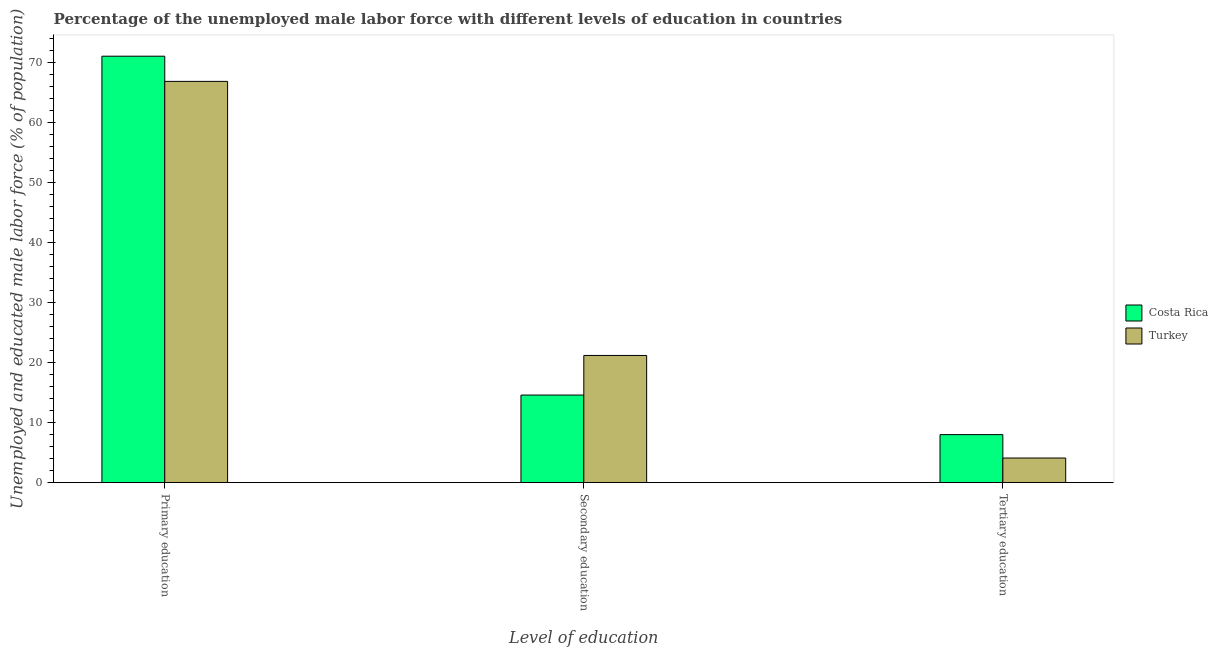How many different coloured bars are there?
Ensure brevity in your answer.  2. How many groups of bars are there?
Make the answer very short. 3. How many bars are there on the 1st tick from the right?
Give a very brief answer. 2. What is the label of the 2nd group of bars from the left?
Give a very brief answer. Secondary education. What is the percentage of male labor force who received secondary education in Costa Rica?
Your answer should be very brief. 14.6. Across all countries, what is the maximum percentage of male labor force who received secondary education?
Ensure brevity in your answer.  21.2. Across all countries, what is the minimum percentage of male labor force who received secondary education?
Your response must be concise. 14.6. In which country was the percentage of male labor force who received secondary education minimum?
Provide a short and direct response. Costa Rica. What is the total percentage of male labor force who received secondary education in the graph?
Give a very brief answer. 35.8. What is the difference between the percentage of male labor force who received secondary education in Costa Rica and that in Turkey?
Offer a very short reply. -6.6. What is the difference between the percentage of male labor force who received primary education in Turkey and the percentage of male labor force who received tertiary education in Costa Rica?
Make the answer very short. 58.9. What is the average percentage of male labor force who received primary education per country?
Make the answer very short. 69. What is the difference between the percentage of male labor force who received tertiary education and percentage of male labor force who received primary education in Costa Rica?
Provide a short and direct response. -63.1. In how many countries, is the percentage of male labor force who received primary education greater than 28 %?
Your answer should be very brief. 2. What is the ratio of the percentage of male labor force who received primary education in Costa Rica to that in Turkey?
Your answer should be compact. 1.06. Is the percentage of male labor force who received tertiary education in Costa Rica less than that in Turkey?
Your answer should be compact. No. Is the difference between the percentage of male labor force who received tertiary education in Costa Rica and Turkey greater than the difference between the percentage of male labor force who received secondary education in Costa Rica and Turkey?
Offer a terse response. Yes. What is the difference between the highest and the second highest percentage of male labor force who received tertiary education?
Make the answer very short. 3.9. What is the difference between the highest and the lowest percentage of male labor force who received tertiary education?
Provide a succinct answer. 3.9. How many bars are there?
Give a very brief answer. 6. How many countries are there in the graph?
Offer a very short reply. 2. Are the values on the major ticks of Y-axis written in scientific E-notation?
Ensure brevity in your answer.  No. Does the graph contain grids?
Keep it short and to the point. No. How many legend labels are there?
Your response must be concise. 2. How are the legend labels stacked?
Ensure brevity in your answer.  Vertical. What is the title of the graph?
Provide a short and direct response. Percentage of the unemployed male labor force with different levels of education in countries. Does "Tunisia" appear as one of the legend labels in the graph?
Provide a succinct answer. No. What is the label or title of the X-axis?
Offer a very short reply. Level of education. What is the label or title of the Y-axis?
Offer a terse response. Unemployed and educated male labor force (% of population). What is the Unemployed and educated male labor force (% of population) in Costa Rica in Primary education?
Make the answer very short. 71.1. What is the Unemployed and educated male labor force (% of population) of Turkey in Primary education?
Your response must be concise. 66.9. What is the Unemployed and educated male labor force (% of population) in Costa Rica in Secondary education?
Offer a terse response. 14.6. What is the Unemployed and educated male labor force (% of population) in Turkey in Secondary education?
Make the answer very short. 21.2. What is the Unemployed and educated male labor force (% of population) of Costa Rica in Tertiary education?
Your answer should be very brief. 8. What is the Unemployed and educated male labor force (% of population) of Turkey in Tertiary education?
Give a very brief answer. 4.1. Across all Level of education, what is the maximum Unemployed and educated male labor force (% of population) of Costa Rica?
Offer a very short reply. 71.1. Across all Level of education, what is the maximum Unemployed and educated male labor force (% of population) in Turkey?
Give a very brief answer. 66.9. Across all Level of education, what is the minimum Unemployed and educated male labor force (% of population) of Costa Rica?
Ensure brevity in your answer.  8. Across all Level of education, what is the minimum Unemployed and educated male labor force (% of population) of Turkey?
Make the answer very short. 4.1. What is the total Unemployed and educated male labor force (% of population) in Costa Rica in the graph?
Offer a very short reply. 93.7. What is the total Unemployed and educated male labor force (% of population) in Turkey in the graph?
Provide a succinct answer. 92.2. What is the difference between the Unemployed and educated male labor force (% of population) of Costa Rica in Primary education and that in Secondary education?
Make the answer very short. 56.5. What is the difference between the Unemployed and educated male labor force (% of population) of Turkey in Primary education and that in Secondary education?
Your answer should be very brief. 45.7. What is the difference between the Unemployed and educated male labor force (% of population) in Costa Rica in Primary education and that in Tertiary education?
Ensure brevity in your answer.  63.1. What is the difference between the Unemployed and educated male labor force (% of population) of Turkey in Primary education and that in Tertiary education?
Offer a very short reply. 62.8. What is the difference between the Unemployed and educated male labor force (% of population) of Costa Rica in Secondary education and that in Tertiary education?
Provide a short and direct response. 6.6. What is the difference between the Unemployed and educated male labor force (% of population) of Costa Rica in Primary education and the Unemployed and educated male labor force (% of population) of Turkey in Secondary education?
Provide a succinct answer. 49.9. What is the difference between the Unemployed and educated male labor force (% of population) of Costa Rica in Primary education and the Unemployed and educated male labor force (% of population) of Turkey in Tertiary education?
Provide a short and direct response. 67. What is the average Unemployed and educated male labor force (% of population) of Costa Rica per Level of education?
Your answer should be very brief. 31.23. What is the average Unemployed and educated male labor force (% of population) in Turkey per Level of education?
Provide a short and direct response. 30.73. What is the ratio of the Unemployed and educated male labor force (% of population) in Costa Rica in Primary education to that in Secondary education?
Provide a short and direct response. 4.87. What is the ratio of the Unemployed and educated male labor force (% of population) of Turkey in Primary education to that in Secondary education?
Your answer should be compact. 3.16. What is the ratio of the Unemployed and educated male labor force (% of population) in Costa Rica in Primary education to that in Tertiary education?
Your answer should be compact. 8.89. What is the ratio of the Unemployed and educated male labor force (% of population) of Turkey in Primary education to that in Tertiary education?
Your answer should be compact. 16.32. What is the ratio of the Unemployed and educated male labor force (% of population) in Costa Rica in Secondary education to that in Tertiary education?
Provide a short and direct response. 1.82. What is the ratio of the Unemployed and educated male labor force (% of population) in Turkey in Secondary education to that in Tertiary education?
Give a very brief answer. 5.17. What is the difference between the highest and the second highest Unemployed and educated male labor force (% of population) of Costa Rica?
Your answer should be compact. 56.5. What is the difference between the highest and the second highest Unemployed and educated male labor force (% of population) of Turkey?
Provide a short and direct response. 45.7. What is the difference between the highest and the lowest Unemployed and educated male labor force (% of population) in Costa Rica?
Your answer should be compact. 63.1. What is the difference between the highest and the lowest Unemployed and educated male labor force (% of population) in Turkey?
Offer a very short reply. 62.8. 